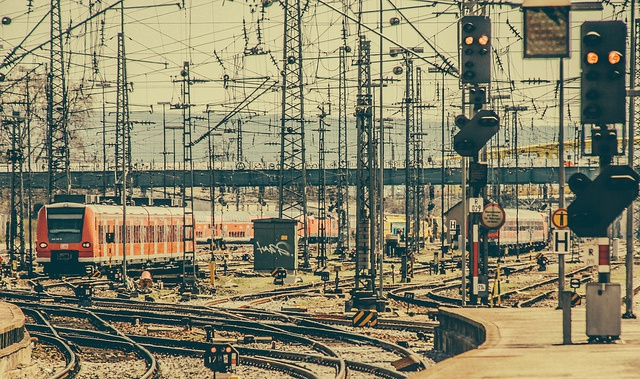Describe the objects in this image and their specific colors. I can see train in tan, black, and khaki tones, traffic light in tan, black, purple, gray, and darkblue tones, and traffic light in tan, purple, black, gray, and darkblue tones in this image. 